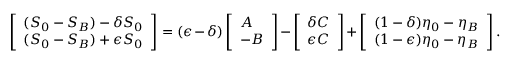Convert formula to latex. <formula><loc_0><loc_0><loc_500><loc_500>\left [ \begin{array} { l } { ( S _ { 0 } - S _ { B } ) - \delta S _ { 0 } } \\ { ( S _ { 0 } - S _ { B } ) + \epsilon S _ { 0 } } \end{array} \right ] = ( \epsilon - \delta ) \left [ \begin{array} { l } { A } \\ { - B } \end{array} \right ] - \left [ \begin{array} { l } { \delta C } \\ { \epsilon C } \end{array} \right ] + \left [ \begin{array} { l } { ( 1 - \delta ) \eta _ { 0 } - \eta _ { B } } \\ { ( 1 - \epsilon ) \eta _ { 0 } - \eta _ { B } } \end{array} \right ] .</formula> 